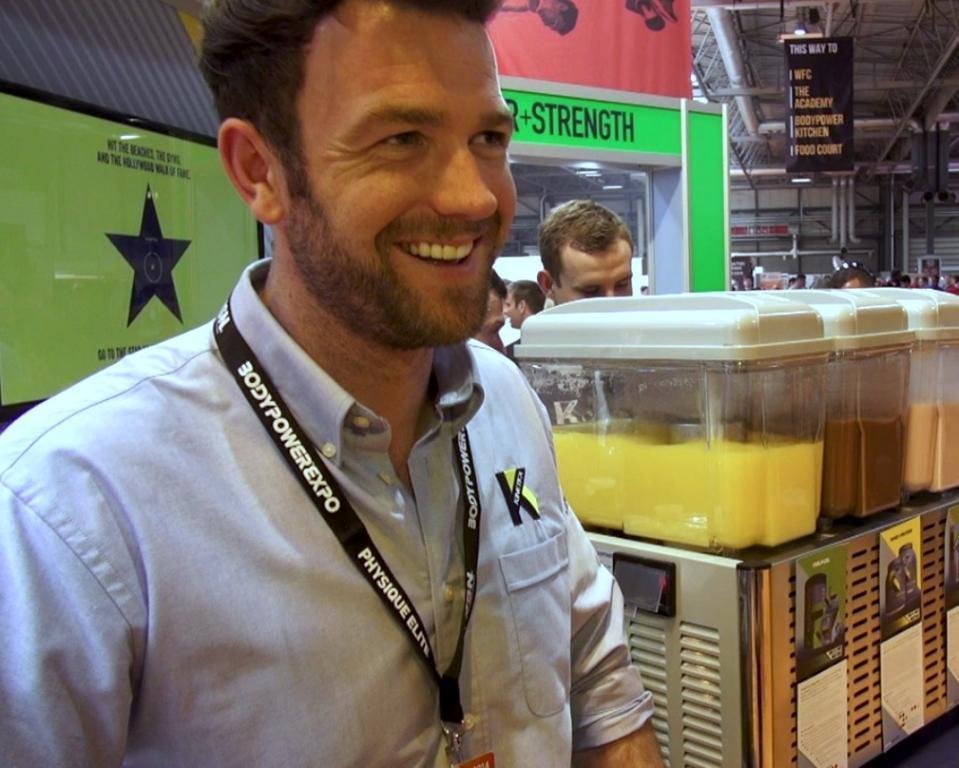Please provide a concise description of this image. In the foreground of this image, there is a man wearing an ID card. Behind him, there are few containers which look like juicers and in the background, there are few people, a banner to the roof of the shed and it seems like there is a stall behind the person. 